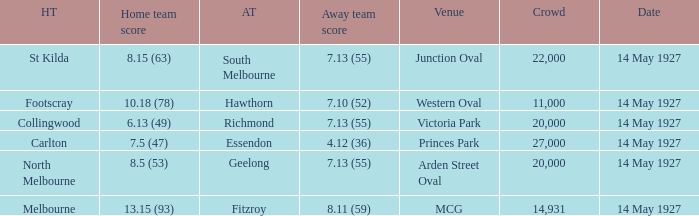Which away team had a score of 7.13 (55) against the home team North Melbourne? Geelong. 